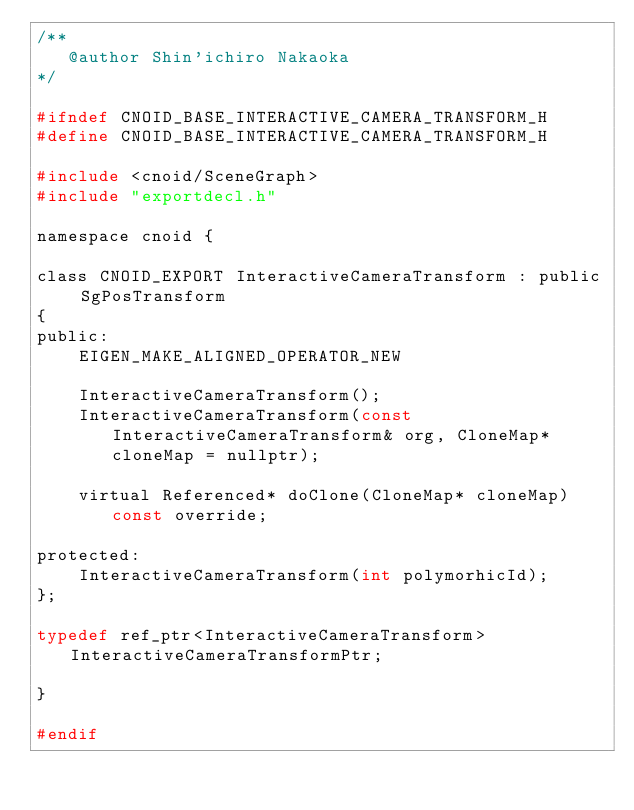<code> <loc_0><loc_0><loc_500><loc_500><_C_>/**
   @author Shin'ichiro Nakaoka
*/

#ifndef CNOID_BASE_INTERACTIVE_CAMERA_TRANSFORM_H
#define CNOID_BASE_INTERACTIVE_CAMERA_TRANSFORM_H

#include <cnoid/SceneGraph>
#include "exportdecl.h"

namespace cnoid {

class CNOID_EXPORT InteractiveCameraTransform : public SgPosTransform
{
public:
    EIGEN_MAKE_ALIGNED_OPERATOR_NEW

    InteractiveCameraTransform();
    InteractiveCameraTransform(const InteractiveCameraTransform& org, CloneMap* cloneMap = nullptr);

    virtual Referenced* doClone(CloneMap* cloneMap) const override;

protected:
    InteractiveCameraTransform(int polymorhicId);
};

typedef ref_ptr<InteractiveCameraTransform> InteractiveCameraTransformPtr;

}

#endif
</code> 